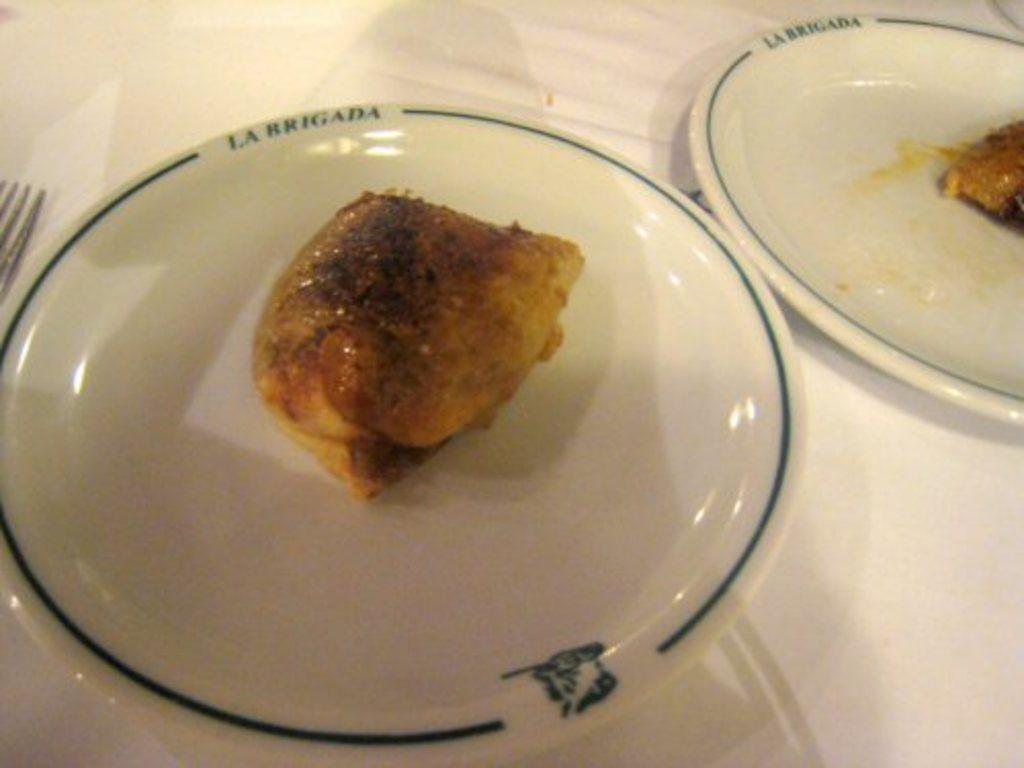How would you summarize this image in a sentence or two? In this image we can see food items in the plates and fork are on a platform. 